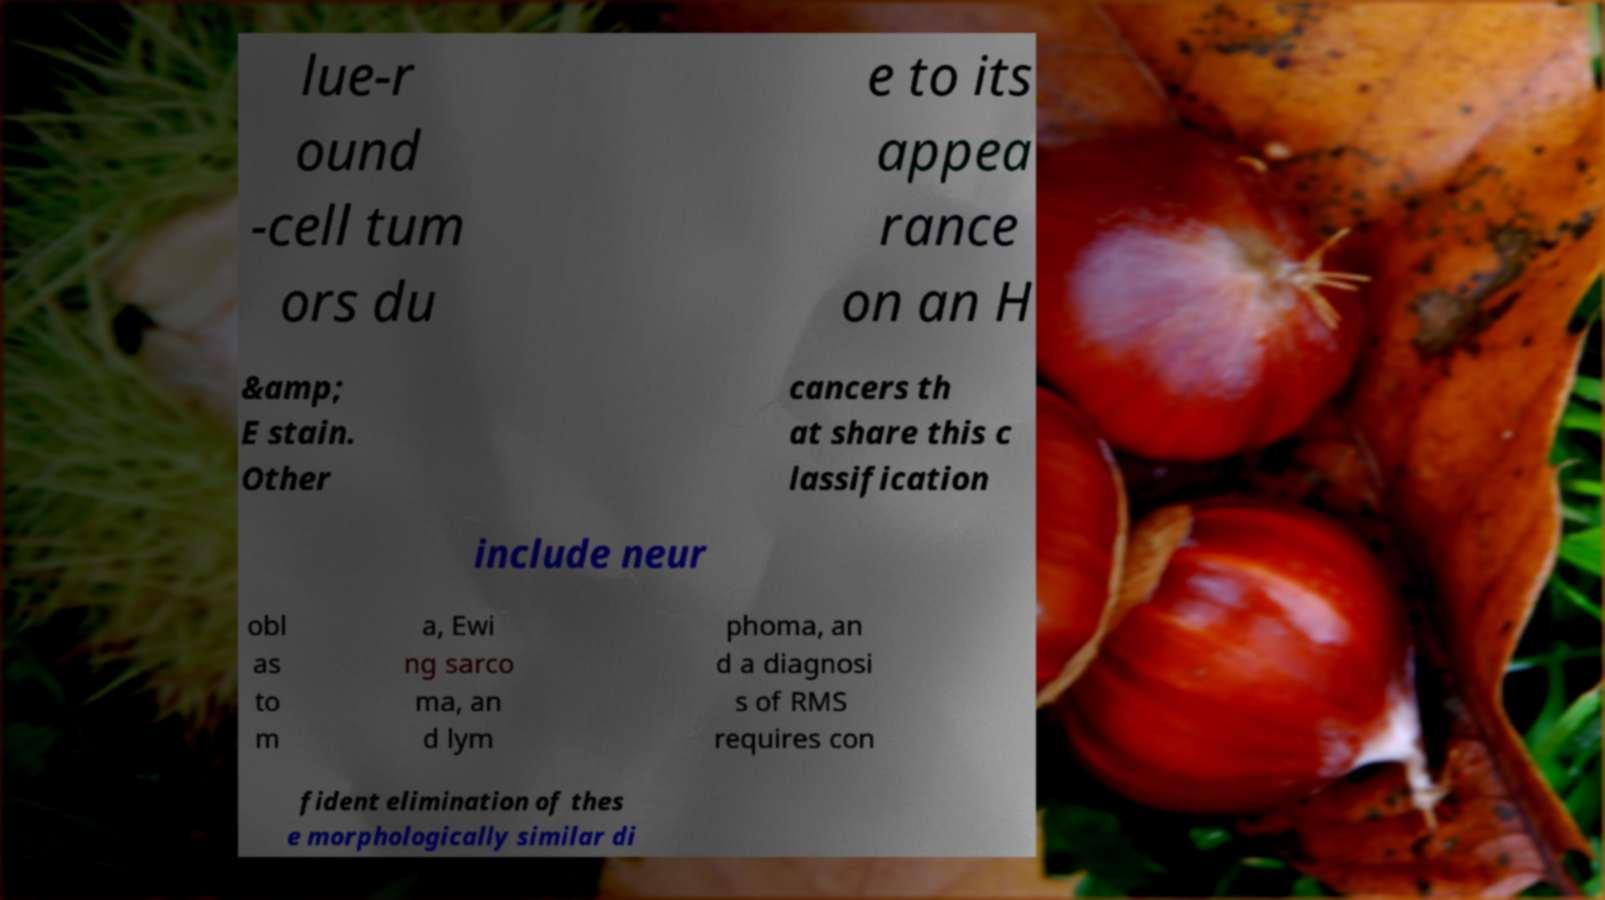Please identify and transcribe the text found in this image. lue-r ound -cell tum ors du e to its appea rance on an H &amp; E stain. Other cancers th at share this c lassification include neur obl as to m a, Ewi ng sarco ma, an d lym phoma, an d a diagnosi s of RMS requires con fident elimination of thes e morphologically similar di 